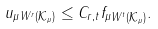<formula> <loc_0><loc_0><loc_500><loc_500>\| u _ { \mu } \| _ { W ^ { r } ( \mathcal { K } _ { \mu } ) } \leq C _ { r , t } \| f _ { \mu } \| _ { W ^ { t } ( \mathcal { K } _ { \mu } ) } .</formula> 